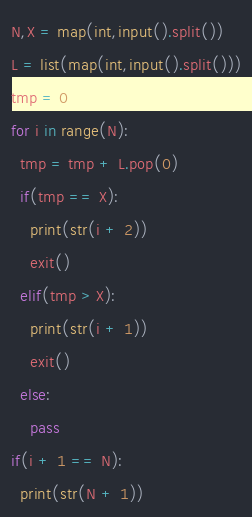Convert code to text. <code><loc_0><loc_0><loc_500><loc_500><_Python_>N,X = map(int,input().split())
L = list(map(int,input().split()))
tmp = 0
for i in range(N):
  tmp = tmp + L.pop(0)
  if(tmp == X):
    print(str(i + 2))
    exit()
  elif(tmp > X):
    print(str(i + 1))
    exit()
  else:
    pass
if(i + 1 == N):
  print(str(N + 1))</code> 